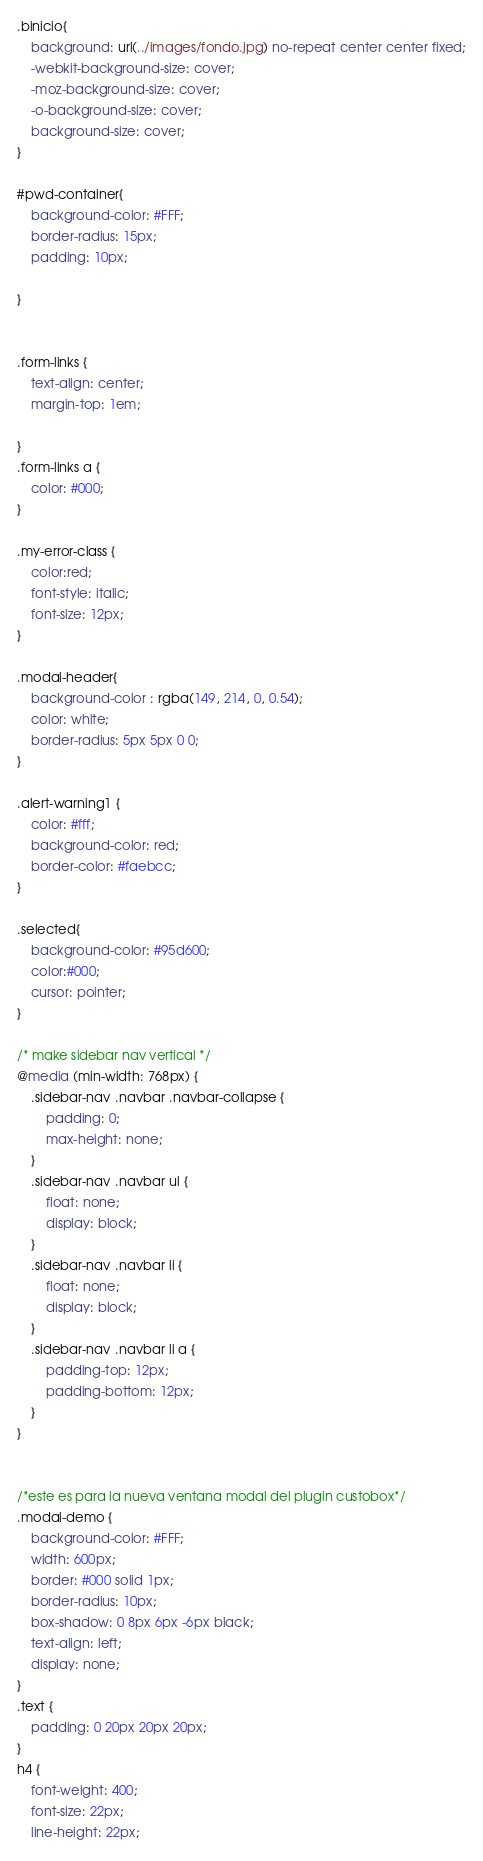<code> <loc_0><loc_0><loc_500><loc_500><_CSS_>.binicio{
    background: url(../images/fondo.jpg) no-repeat center center fixed;
    -webkit-background-size: cover;
    -moz-background-size: cover;
    -o-background-size: cover;
    background-size: cover;
}

#pwd-container{
    background-color: #FFF;
    border-radius: 15px;
    padding: 10px;

}


.form-links {
    text-align: center;
    margin-top: 1em;

}
.form-links a {
    color: #000;
}

.my-error-class {
    color:red;
    font-style: italic;
    font-size: 12px;
}

.modal-header{
    background-color : rgba(149, 214, 0, 0.54);
    color: white;
    border-radius: 5px 5px 0 0;
}

.alert-warning1 {
    color: #fff;
    background-color: red;
    border-color: #faebcc;
}

.selected{
    background-color: #95d600;
    color:#000;
    cursor: pointer;
}

/* make sidebar nav vertical */ 
@media (min-width: 768px) {
    .sidebar-nav .navbar .navbar-collapse {
        padding: 0;
        max-height: none;
    }
    .sidebar-nav .navbar ul {
        float: none;
        display: block;
    }
    .sidebar-nav .navbar li {
        float: none;
        display: block;
    }
    .sidebar-nav .navbar li a {
        padding-top: 12px;
        padding-bottom: 12px;
    }
}


/*este es para la nueva ventana modal del plugin custobox*/
.modal-demo {
    background-color: #FFF;
    width: 600px;
    border: #000 solid 1px;
    border-radius: 10px;
    box-shadow: 0 8px 6px -6px black;
    text-align: left;
    display: none;
}
.text {
    padding: 0 20px 20px 20px;
}
h4 {
    font-weight: 400;
    font-size: 22px;
    line-height: 22px;</code> 